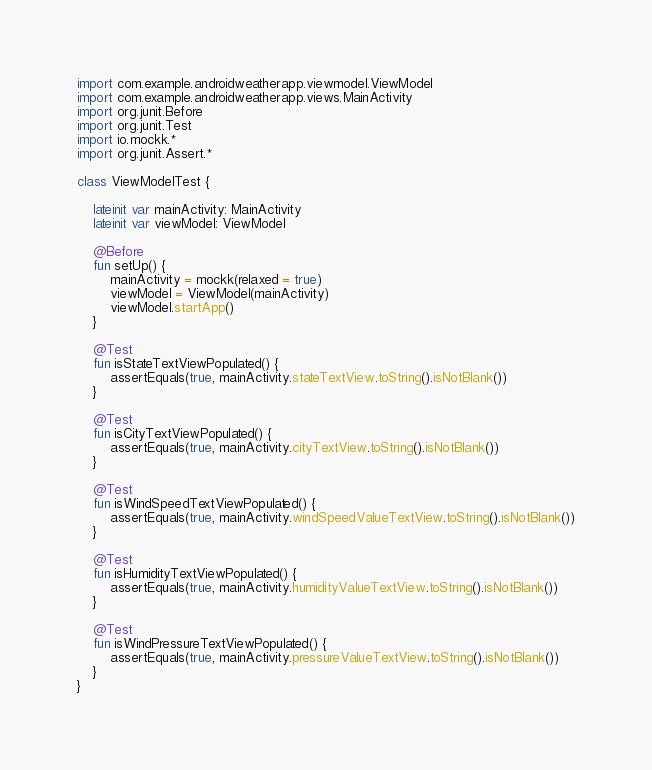Convert code to text. <code><loc_0><loc_0><loc_500><loc_500><_Kotlin_>
import com.example.androidweatherapp.viewmodel.ViewModel
import com.example.androidweatherapp.views.MainActivity
import org.junit.Before
import org.junit.Test
import io.mockk.*
import org.junit.Assert.*

class ViewModelTest {

    lateinit var mainActivity: MainActivity
    lateinit var viewModel: ViewModel

    @Before
    fun setUp() {
        mainActivity = mockk(relaxed = true)
        viewModel = ViewModel(mainActivity)
        viewModel.startApp()
    }

    @Test
    fun isStateTextViewPopulated() {
        assertEquals(true, mainActivity.stateTextView.toString().isNotBlank())
    }

    @Test
    fun isCityTextViewPopulated() {
        assertEquals(true, mainActivity.cityTextView.toString().isNotBlank())
    }

    @Test
    fun isWindSpeedTextViewPopulated() {
        assertEquals(true, mainActivity.windSpeedValueTextView.toString().isNotBlank())
    }

    @Test
    fun isHumidityTextViewPopulated() {
        assertEquals(true, mainActivity.humidityValueTextView.toString().isNotBlank())
    }

    @Test
    fun isWindPressureTextViewPopulated() {
        assertEquals(true, mainActivity.pressureValueTextView.toString().isNotBlank())
    }
}</code> 